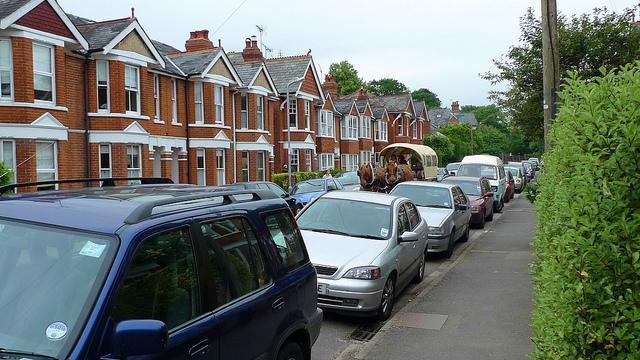How many cars are on the near side of the street?
Give a very brief answer. 10. How many cars are there?
Give a very brief answer. 3. 